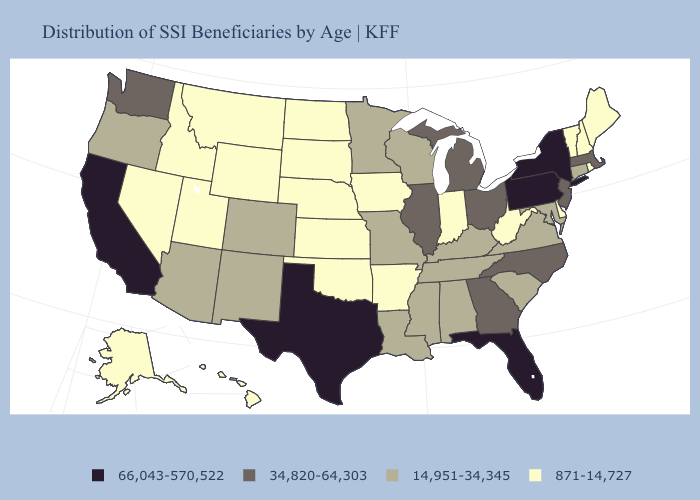Does Nevada have the lowest value in the West?
Answer briefly. Yes. Does Massachusetts have the lowest value in the USA?
Concise answer only. No. Does Indiana have the lowest value in the MidWest?
Be succinct. Yes. What is the value of Arkansas?
Write a very short answer. 871-14,727. Is the legend a continuous bar?
Give a very brief answer. No. Is the legend a continuous bar?
Answer briefly. No. How many symbols are there in the legend?
Be succinct. 4. Which states have the lowest value in the South?
Short answer required. Arkansas, Delaware, Oklahoma, West Virginia. Does Connecticut have a higher value than Oklahoma?
Be succinct. Yes. What is the value of California?
Give a very brief answer. 66,043-570,522. Which states hav the highest value in the West?
Quick response, please. California. What is the value of Georgia?
Write a very short answer. 34,820-64,303. Name the states that have a value in the range 871-14,727?
Short answer required. Alaska, Arkansas, Delaware, Hawaii, Idaho, Indiana, Iowa, Kansas, Maine, Montana, Nebraska, Nevada, New Hampshire, North Dakota, Oklahoma, Rhode Island, South Dakota, Utah, Vermont, West Virginia, Wyoming. Among the states that border Georgia , does South Carolina have the lowest value?
Give a very brief answer. Yes. Among the states that border Texas , which have the highest value?
Keep it brief. Louisiana, New Mexico. 